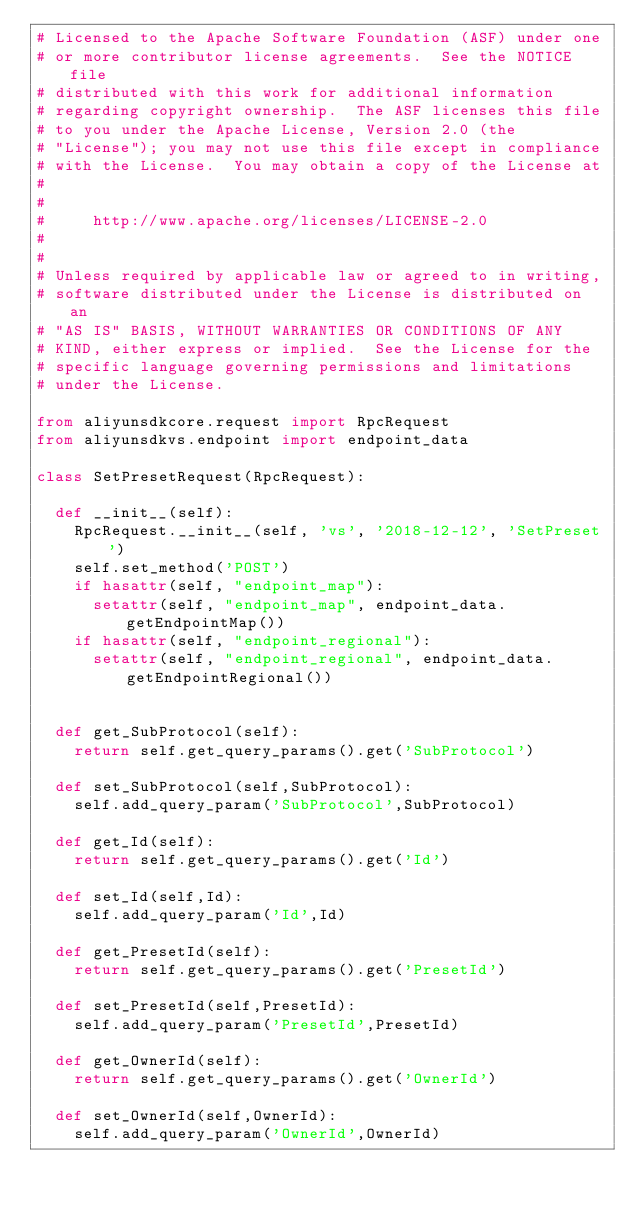Convert code to text. <code><loc_0><loc_0><loc_500><loc_500><_Python_># Licensed to the Apache Software Foundation (ASF) under one
# or more contributor license agreements.  See the NOTICE file
# distributed with this work for additional information
# regarding copyright ownership.  The ASF licenses this file
# to you under the Apache License, Version 2.0 (the
# "License"); you may not use this file except in compliance
# with the License.  You may obtain a copy of the License at
#
#
#     http://www.apache.org/licenses/LICENSE-2.0
#
#
# Unless required by applicable law or agreed to in writing,
# software distributed under the License is distributed on an
# "AS IS" BASIS, WITHOUT WARRANTIES OR CONDITIONS OF ANY
# KIND, either express or implied.  See the License for the
# specific language governing permissions and limitations
# under the License.

from aliyunsdkcore.request import RpcRequest
from aliyunsdkvs.endpoint import endpoint_data

class SetPresetRequest(RpcRequest):

	def __init__(self):
		RpcRequest.__init__(self, 'vs', '2018-12-12', 'SetPreset')
		self.set_method('POST')
		if hasattr(self, "endpoint_map"):
			setattr(self, "endpoint_map", endpoint_data.getEndpointMap())
		if hasattr(self, "endpoint_regional"):
			setattr(self, "endpoint_regional", endpoint_data.getEndpointRegional())


	def get_SubProtocol(self):
		return self.get_query_params().get('SubProtocol')

	def set_SubProtocol(self,SubProtocol):
		self.add_query_param('SubProtocol',SubProtocol)

	def get_Id(self):
		return self.get_query_params().get('Id')

	def set_Id(self,Id):
		self.add_query_param('Id',Id)

	def get_PresetId(self):
		return self.get_query_params().get('PresetId')

	def set_PresetId(self,PresetId):
		self.add_query_param('PresetId',PresetId)

	def get_OwnerId(self):
		return self.get_query_params().get('OwnerId')

	def set_OwnerId(self,OwnerId):
		self.add_query_param('OwnerId',OwnerId)</code> 